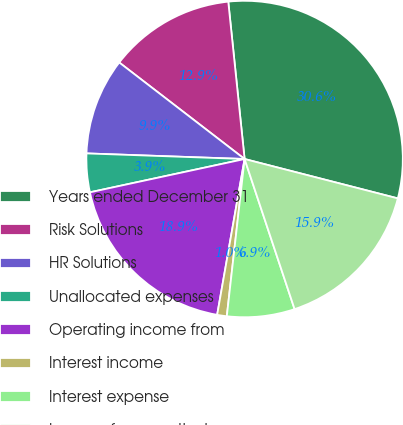Convert chart to OTSL. <chart><loc_0><loc_0><loc_500><loc_500><pie_chart><fcel>Years ended December 31<fcel>Risk Solutions<fcel>HR Solutions<fcel>Unallocated expenses<fcel>Operating income from<fcel>Interest income<fcel>Interest expense<fcel>Income from continuing<nl><fcel>30.65%<fcel>12.91%<fcel>9.88%<fcel>3.94%<fcel>18.85%<fcel>0.98%<fcel>6.91%<fcel>15.88%<nl></chart> 